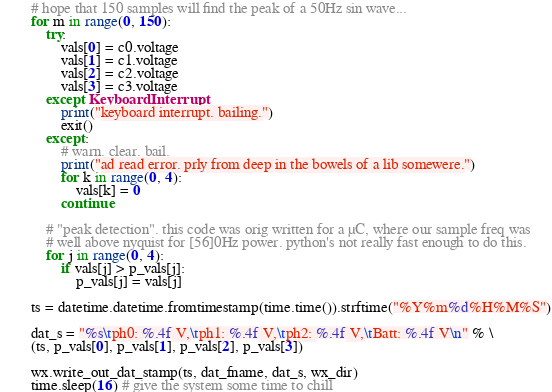Convert code to text. <code><loc_0><loc_0><loc_500><loc_500><_Python_>
		# hope that 150 samples will find the peak of a 50Hz sin wave...
		for m in range(0, 150):
			try:
				vals[0] = c0.voltage
				vals[1] = c1.voltage
				vals[2] = c2.voltage
				vals[3] = c3.voltage
			except KeyboardInterrupt:
				print("keyboard interrupt. bailing.")
				exit()
			except:
				# warn. clear. bail.
				print("ad read error. prly from deep in the bowels of a lib somewere.")
				for k in range(0, 4):
					vals[k] = 0
				continue

			# "peak detection". this code was orig written for a µC, where our sample freq was
			# well above nyquist for [56]0Hz power. python's not really fast enough to do this.
			for j in range(0, 4):
				if vals[j] > p_vals[j]:
					p_vals[j] = vals[j]

		ts = datetime.datetime.fromtimestamp(time.time()).strftime("%Y%m%d%H%M%S")

		dat_s = "%s\tph0: %.4f V,\tph1: %.4f V,\tph2: %.4f V,\tBatt: %.4f V\n" % \
		(ts, p_vals[0], p_vals[1], p_vals[2], p_vals[3])

		wx.write_out_dat_stamp(ts, dat_fname, dat_s, wx_dir)
		time.sleep(16) # give the system some time to chill
</code> 